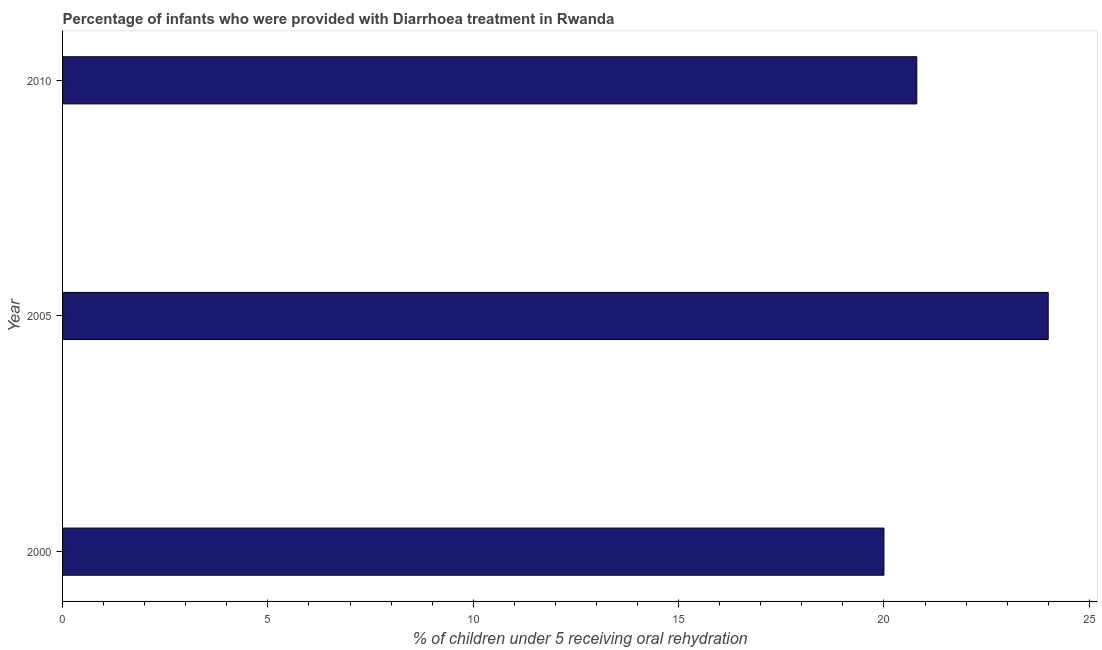Does the graph contain any zero values?
Keep it short and to the point. No. Does the graph contain grids?
Ensure brevity in your answer.  No. What is the title of the graph?
Ensure brevity in your answer.  Percentage of infants who were provided with Diarrhoea treatment in Rwanda. What is the label or title of the X-axis?
Provide a succinct answer. % of children under 5 receiving oral rehydration. What is the label or title of the Y-axis?
Your response must be concise. Year. What is the percentage of children who were provided with treatment diarrhoea in 2005?
Make the answer very short. 24. Across all years, what is the minimum percentage of children who were provided with treatment diarrhoea?
Provide a succinct answer. 20. In which year was the percentage of children who were provided with treatment diarrhoea minimum?
Provide a succinct answer. 2000. What is the sum of the percentage of children who were provided with treatment diarrhoea?
Offer a terse response. 64.8. What is the difference between the percentage of children who were provided with treatment diarrhoea in 2000 and 2005?
Offer a terse response. -4. What is the average percentage of children who were provided with treatment diarrhoea per year?
Your answer should be very brief. 21.6. What is the median percentage of children who were provided with treatment diarrhoea?
Provide a succinct answer. 20.8. Do a majority of the years between 2000 and 2005 (inclusive) have percentage of children who were provided with treatment diarrhoea greater than 4 %?
Make the answer very short. Yes. What is the ratio of the percentage of children who were provided with treatment diarrhoea in 2000 to that in 2005?
Your response must be concise. 0.83. Is the percentage of children who were provided with treatment diarrhoea in 2000 less than that in 2005?
Provide a succinct answer. Yes. Is the difference between the percentage of children who were provided with treatment diarrhoea in 2005 and 2010 greater than the difference between any two years?
Your response must be concise. No. Is the sum of the percentage of children who were provided with treatment diarrhoea in 2005 and 2010 greater than the maximum percentage of children who were provided with treatment diarrhoea across all years?
Give a very brief answer. Yes. In how many years, is the percentage of children who were provided with treatment diarrhoea greater than the average percentage of children who were provided with treatment diarrhoea taken over all years?
Keep it short and to the point. 1. Are all the bars in the graph horizontal?
Provide a short and direct response. Yes. Are the values on the major ticks of X-axis written in scientific E-notation?
Ensure brevity in your answer.  No. What is the % of children under 5 receiving oral rehydration of 2005?
Ensure brevity in your answer.  24. What is the % of children under 5 receiving oral rehydration of 2010?
Provide a succinct answer. 20.8. What is the difference between the % of children under 5 receiving oral rehydration in 2000 and 2010?
Give a very brief answer. -0.8. What is the ratio of the % of children under 5 receiving oral rehydration in 2000 to that in 2005?
Ensure brevity in your answer.  0.83. What is the ratio of the % of children under 5 receiving oral rehydration in 2005 to that in 2010?
Keep it short and to the point. 1.15. 